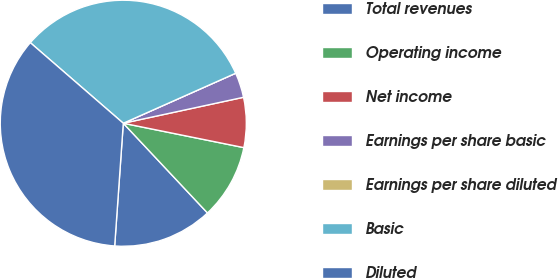<chart> <loc_0><loc_0><loc_500><loc_500><pie_chart><fcel>Total revenues<fcel>Operating income<fcel>Net income<fcel>Earnings per share basic<fcel>Earnings per share diluted<fcel>Basic<fcel>Diluted<nl><fcel>13.11%<fcel>9.83%<fcel>6.56%<fcel>3.28%<fcel>0.0%<fcel>31.97%<fcel>35.25%<nl></chart> 